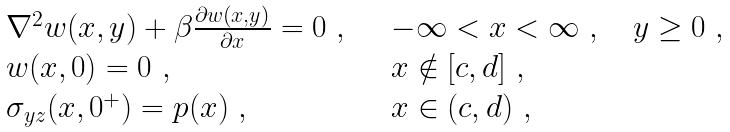Convert formula to latex. <formula><loc_0><loc_0><loc_500><loc_500>\begin{array} { l l } \nabla ^ { 2 } w ( x , y ) + \beta \frac { \partial w ( x , y ) } { \partial x } = 0 \ , & \quad - \infty < x < \infty \ , \quad y \geq 0 \ , \\ w ( x , 0 ) = 0 \ , & \quad x \notin [ c , d ] \ , \\ \sigma _ { y z } ( x , 0 ^ { + } ) = p ( x ) \ , & \quad x \in ( c , d ) \ , \end{array}</formula> 